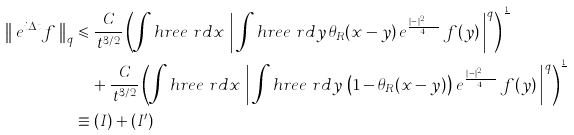<formula> <loc_0><loc_0><loc_500><loc_500>\left \| \, e ^ { i \Delta t } f \, \right \| _ { q } & \leqslant \frac { \, C } { \, t ^ { 3 / 2 } } \left ( \int h r e e \ r d x \, \left | \, \int h r e e \ r d y \, \theta _ { R } ( x - y ) \, e ^ { \frac { i | x - y | ^ { 2 } } { 4 t } } \, f ( y ) \, \right | ^ { q } \right ) ^ { \frac { 1 } { q } } \\ & \quad + \frac { \, C } { \, t ^ { 3 / 2 } } \left ( \int h r e e \ r d x \, \left | \, \int h r e e \ r d y \, \left ( 1 - \theta _ { R } ( x - y ) \right ) \, e ^ { \frac { i | x - y | ^ { 2 } } { 4 t } } \, f ( y ) \, \right | ^ { q } \right ) ^ { \frac { 1 } { q } } \\ & \equiv ( I ) + ( I ^ { \prime } )</formula> 